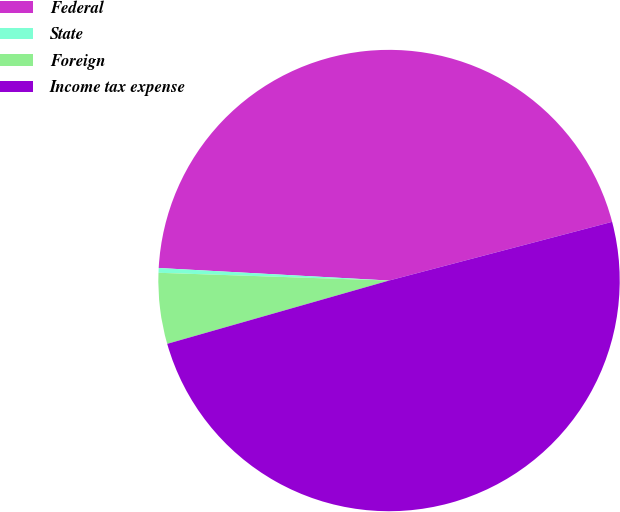Convert chart. <chart><loc_0><loc_0><loc_500><loc_500><pie_chart><fcel>Federal<fcel>State<fcel>Foreign<fcel>Income tax expense<nl><fcel>45.04%<fcel>0.33%<fcel>4.96%<fcel>49.67%<nl></chart> 